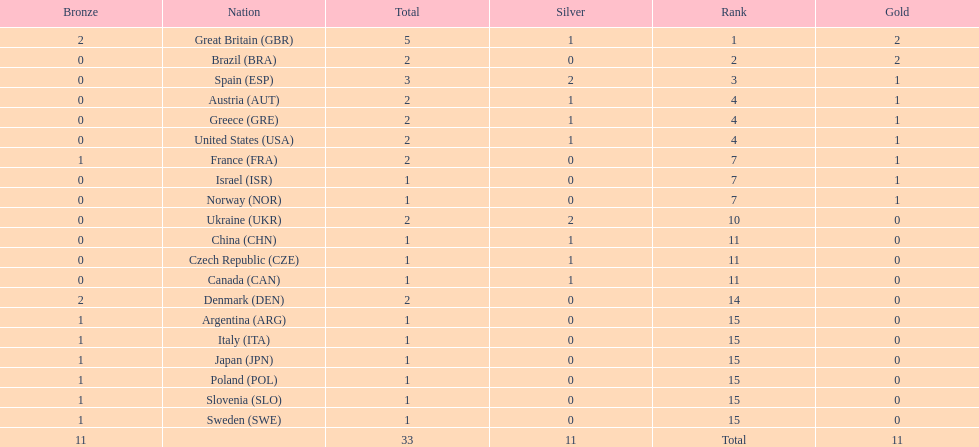Could you help me parse every detail presented in this table? {'header': ['Bronze', 'Nation', 'Total', 'Silver', 'Rank', 'Gold'], 'rows': [['2', 'Great Britain\xa0(GBR)', '5', '1', '1', '2'], ['0', 'Brazil\xa0(BRA)', '2', '0', '2', '2'], ['0', 'Spain\xa0(ESP)', '3', '2', '3', '1'], ['0', 'Austria\xa0(AUT)', '2', '1', '4', '1'], ['0', 'Greece\xa0(GRE)', '2', '1', '4', '1'], ['0', 'United States\xa0(USA)', '2', '1', '4', '1'], ['1', 'France\xa0(FRA)', '2', '0', '7', '1'], ['0', 'Israel\xa0(ISR)', '1', '0', '7', '1'], ['0', 'Norway\xa0(NOR)', '1', '0', '7', '1'], ['0', 'Ukraine\xa0(UKR)', '2', '2', '10', '0'], ['0', 'China\xa0(CHN)', '1', '1', '11', '0'], ['0', 'Czech Republic\xa0(CZE)', '1', '1', '11', '0'], ['0', 'Canada\xa0(CAN)', '1', '1', '11', '0'], ['2', 'Denmark\xa0(DEN)', '2', '0', '14', '0'], ['1', 'Argentina\xa0(ARG)', '1', '0', '15', '0'], ['1', 'Italy\xa0(ITA)', '1', '0', '15', '0'], ['1', 'Japan\xa0(JPN)', '1', '0', '15', '0'], ['1', 'Poland\xa0(POL)', '1', '0', '15', '0'], ['1', 'Slovenia\xa0(SLO)', '1', '0', '15', '0'], ['1', 'Sweden\xa0(SWE)', '1', '0', '15', '0'], ['11', '', '33', '11', 'Total', '11']]} What was the count of silver medals obtained by ukraine? 2. 